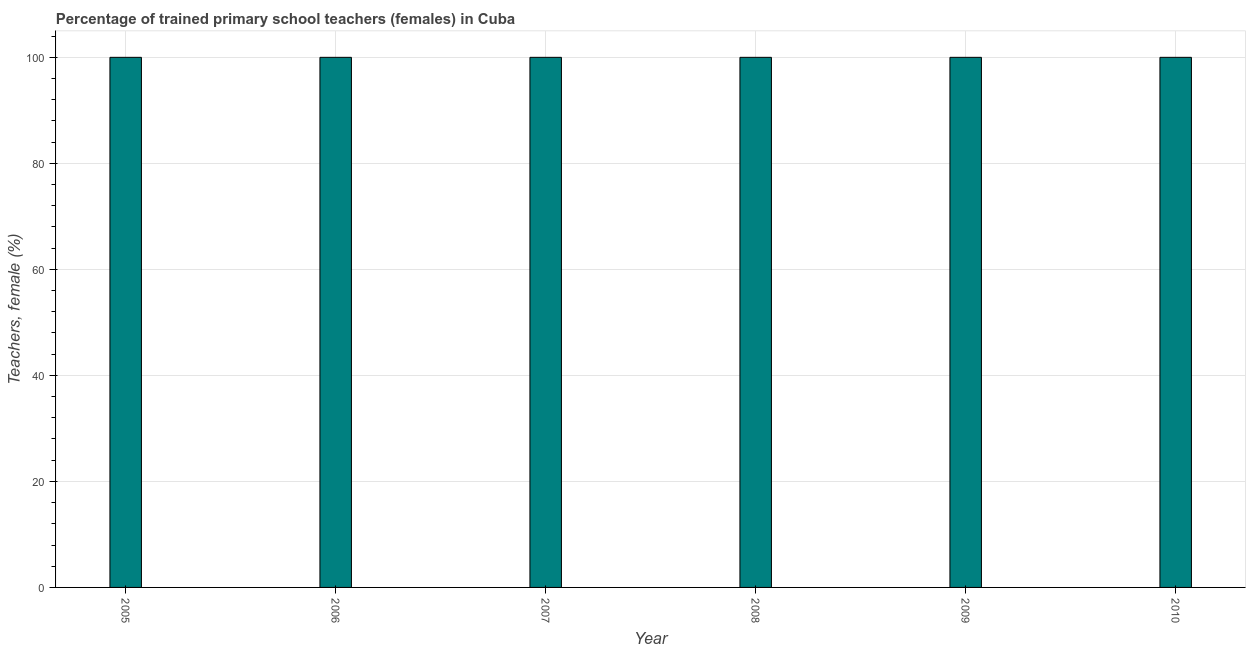Does the graph contain any zero values?
Provide a short and direct response. No. What is the title of the graph?
Ensure brevity in your answer.  Percentage of trained primary school teachers (females) in Cuba. What is the label or title of the Y-axis?
Give a very brief answer. Teachers, female (%). Across all years, what is the minimum percentage of trained female teachers?
Offer a terse response. 100. In which year was the percentage of trained female teachers maximum?
Your answer should be compact. 2005. In which year was the percentage of trained female teachers minimum?
Keep it short and to the point. 2005. What is the sum of the percentage of trained female teachers?
Your answer should be very brief. 600. What is the average percentage of trained female teachers per year?
Offer a very short reply. 100. What is the median percentage of trained female teachers?
Offer a very short reply. 100. Do a majority of the years between 2006 and 2010 (inclusive) have percentage of trained female teachers greater than 96 %?
Make the answer very short. Yes. What is the difference between the highest and the lowest percentage of trained female teachers?
Provide a short and direct response. 0. In how many years, is the percentage of trained female teachers greater than the average percentage of trained female teachers taken over all years?
Keep it short and to the point. 0. Are all the bars in the graph horizontal?
Offer a very short reply. No. How many years are there in the graph?
Provide a succinct answer. 6. Are the values on the major ticks of Y-axis written in scientific E-notation?
Give a very brief answer. No. What is the Teachers, female (%) in 2005?
Make the answer very short. 100. What is the Teachers, female (%) in 2007?
Give a very brief answer. 100. What is the Teachers, female (%) in 2008?
Provide a short and direct response. 100. What is the Teachers, female (%) in 2010?
Your response must be concise. 100. What is the difference between the Teachers, female (%) in 2005 and 2006?
Offer a terse response. 0. What is the difference between the Teachers, female (%) in 2005 and 2008?
Your answer should be very brief. 0. What is the difference between the Teachers, female (%) in 2005 and 2009?
Offer a very short reply. 0. What is the difference between the Teachers, female (%) in 2005 and 2010?
Provide a short and direct response. 0. What is the difference between the Teachers, female (%) in 2006 and 2009?
Give a very brief answer. 0. What is the ratio of the Teachers, female (%) in 2005 to that in 2006?
Give a very brief answer. 1. What is the ratio of the Teachers, female (%) in 2005 to that in 2008?
Your answer should be compact. 1. What is the ratio of the Teachers, female (%) in 2005 to that in 2010?
Ensure brevity in your answer.  1. What is the ratio of the Teachers, female (%) in 2007 to that in 2008?
Ensure brevity in your answer.  1. What is the ratio of the Teachers, female (%) in 2007 to that in 2009?
Your answer should be very brief. 1. What is the ratio of the Teachers, female (%) in 2007 to that in 2010?
Your answer should be very brief. 1. What is the ratio of the Teachers, female (%) in 2008 to that in 2010?
Provide a succinct answer. 1. 